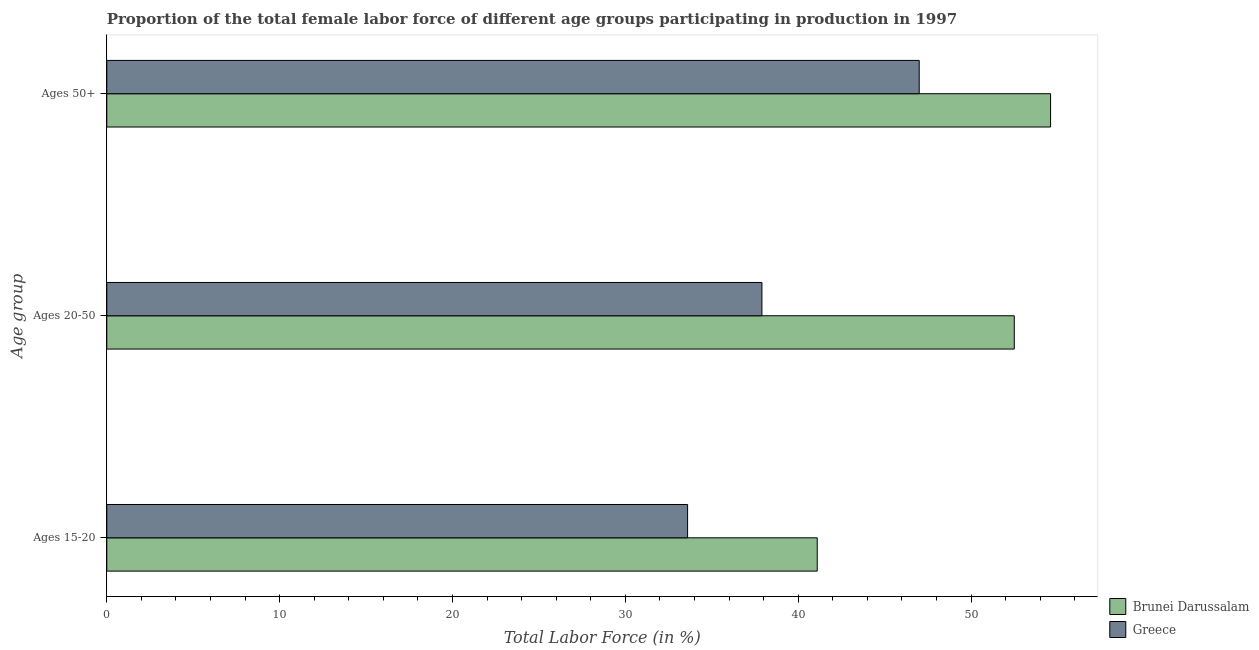Are the number of bars per tick equal to the number of legend labels?
Offer a terse response. Yes. How many bars are there on the 2nd tick from the top?
Provide a short and direct response. 2. How many bars are there on the 3rd tick from the bottom?
Offer a terse response. 2. What is the label of the 3rd group of bars from the top?
Your answer should be very brief. Ages 15-20. What is the percentage of female labor force above age 50 in Brunei Darussalam?
Your response must be concise. 54.6. Across all countries, what is the maximum percentage of female labor force within the age group 20-50?
Provide a short and direct response. 52.5. Across all countries, what is the minimum percentage of female labor force within the age group 15-20?
Keep it short and to the point. 33.6. In which country was the percentage of female labor force within the age group 15-20 maximum?
Your answer should be very brief. Brunei Darussalam. What is the total percentage of female labor force within the age group 20-50 in the graph?
Provide a succinct answer. 90.4. What is the difference between the percentage of female labor force above age 50 in Brunei Darussalam and that in Greece?
Offer a very short reply. 7.6. What is the difference between the percentage of female labor force above age 50 in Greece and the percentage of female labor force within the age group 15-20 in Brunei Darussalam?
Your answer should be very brief. 5.9. What is the average percentage of female labor force within the age group 20-50 per country?
Ensure brevity in your answer.  45.2. What is the difference between the percentage of female labor force within the age group 20-50 and percentage of female labor force above age 50 in Greece?
Give a very brief answer. -9.1. What is the ratio of the percentage of female labor force above age 50 in Greece to that in Brunei Darussalam?
Keep it short and to the point. 0.86. Is the difference between the percentage of female labor force within the age group 15-20 in Greece and Brunei Darussalam greater than the difference between the percentage of female labor force above age 50 in Greece and Brunei Darussalam?
Make the answer very short. Yes. What is the difference between the highest and the second highest percentage of female labor force above age 50?
Provide a short and direct response. 7.6. What is the difference between the highest and the lowest percentage of female labor force above age 50?
Provide a short and direct response. 7.6. What does the 2nd bar from the top in Ages 50+ represents?
Provide a succinct answer. Brunei Darussalam. What does the 1st bar from the bottom in Ages 15-20 represents?
Your answer should be compact. Brunei Darussalam. Is it the case that in every country, the sum of the percentage of female labor force within the age group 15-20 and percentage of female labor force within the age group 20-50 is greater than the percentage of female labor force above age 50?
Make the answer very short. Yes. How many countries are there in the graph?
Make the answer very short. 2. What is the difference between two consecutive major ticks on the X-axis?
Your response must be concise. 10. Are the values on the major ticks of X-axis written in scientific E-notation?
Ensure brevity in your answer.  No. Does the graph contain grids?
Provide a short and direct response. No. How are the legend labels stacked?
Your response must be concise. Vertical. What is the title of the graph?
Offer a very short reply. Proportion of the total female labor force of different age groups participating in production in 1997. What is the label or title of the Y-axis?
Ensure brevity in your answer.  Age group. What is the Total Labor Force (in %) in Brunei Darussalam in Ages 15-20?
Provide a succinct answer. 41.1. What is the Total Labor Force (in %) in Greece in Ages 15-20?
Provide a short and direct response. 33.6. What is the Total Labor Force (in %) in Brunei Darussalam in Ages 20-50?
Your answer should be very brief. 52.5. What is the Total Labor Force (in %) in Greece in Ages 20-50?
Offer a very short reply. 37.9. What is the Total Labor Force (in %) of Brunei Darussalam in Ages 50+?
Provide a succinct answer. 54.6. Across all Age group, what is the maximum Total Labor Force (in %) in Brunei Darussalam?
Make the answer very short. 54.6. Across all Age group, what is the minimum Total Labor Force (in %) in Brunei Darussalam?
Keep it short and to the point. 41.1. Across all Age group, what is the minimum Total Labor Force (in %) of Greece?
Ensure brevity in your answer.  33.6. What is the total Total Labor Force (in %) of Brunei Darussalam in the graph?
Offer a terse response. 148.2. What is the total Total Labor Force (in %) of Greece in the graph?
Provide a succinct answer. 118.5. What is the difference between the Total Labor Force (in %) of Brunei Darussalam in Ages 20-50 and that in Ages 50+?
Your answer should be compact. -2.1. What is the difference between the Total Labor Force (in %) of Brunei Darussalam in Ages 15-20 and the Total Labor Force (in %) of Greece in Ages 20-50?
Provide a short and direct response. 3.2. What is the difference between the Total Labor Force (in %) of Brunei Darussalam in Ages 15-20 and the Total Labor Force (in %) of Greece in Ages 50+?
Ensure brevity in your answer.  -5.9. What is the difference between the Total Labor Force (in %) of Brunei Darussalam in Ages 20-50 and the Total Labor Force (in %) of Greece in Ages 50+?
Ensure brevity in your answer.  5.5. What is the average Total Labor Force (in %) of Brunei Darussalam per Age group?
Your answer should be very brief. 49.4. What is the average Total Labor Force (in %) of Greece per Age group?
Give a very brief answer. 39.5. What is the difference between the Total Labor Force (in %) of Brunei Darussalam and Total Labor Force (in %) of Greece in Ages 15-20?
Offer a very short reply. 7.5. What is the difference between the Total Labor Force (in %) in Brunei Darussalam and Total Labor Force (in %) in Greece in Ages 20-50?
Make the answer very short. 14.6. What is the ratio of the Total Labor Force (in %) in Brunei Darussalam in Ages 15-20 to that in Ages 20-50?
Your answer should be compact. 0.78. What is the ratio of the Total Labor Force (in %) in Greece in Ages 15-20 to that in Ages 20-50?
Ensure brevity in your answer.  0.89. What is the ratio of the Total Labor Force (in %) in Brunei Darussalam in Ages 15-20 to that in Ages 50+?
Provide a short and direct response. 0.75. What is the ratio of the Total Labor Force (in %) of Greece in Ages 15-20 to that in Ages 50+?
Keep it short and to the point. 0.71. What is the ratio of the Total Labor Force (in %) of Brunei Darussalam in Ages 20-50 to that in Ages 50+?
Your answer should be compact. 0.96. What is the ratio of the Total Labor Force (in %) in Greece in Ages 20-50 to that in Ages 50+?
Give a very brief answer. 0.81. 